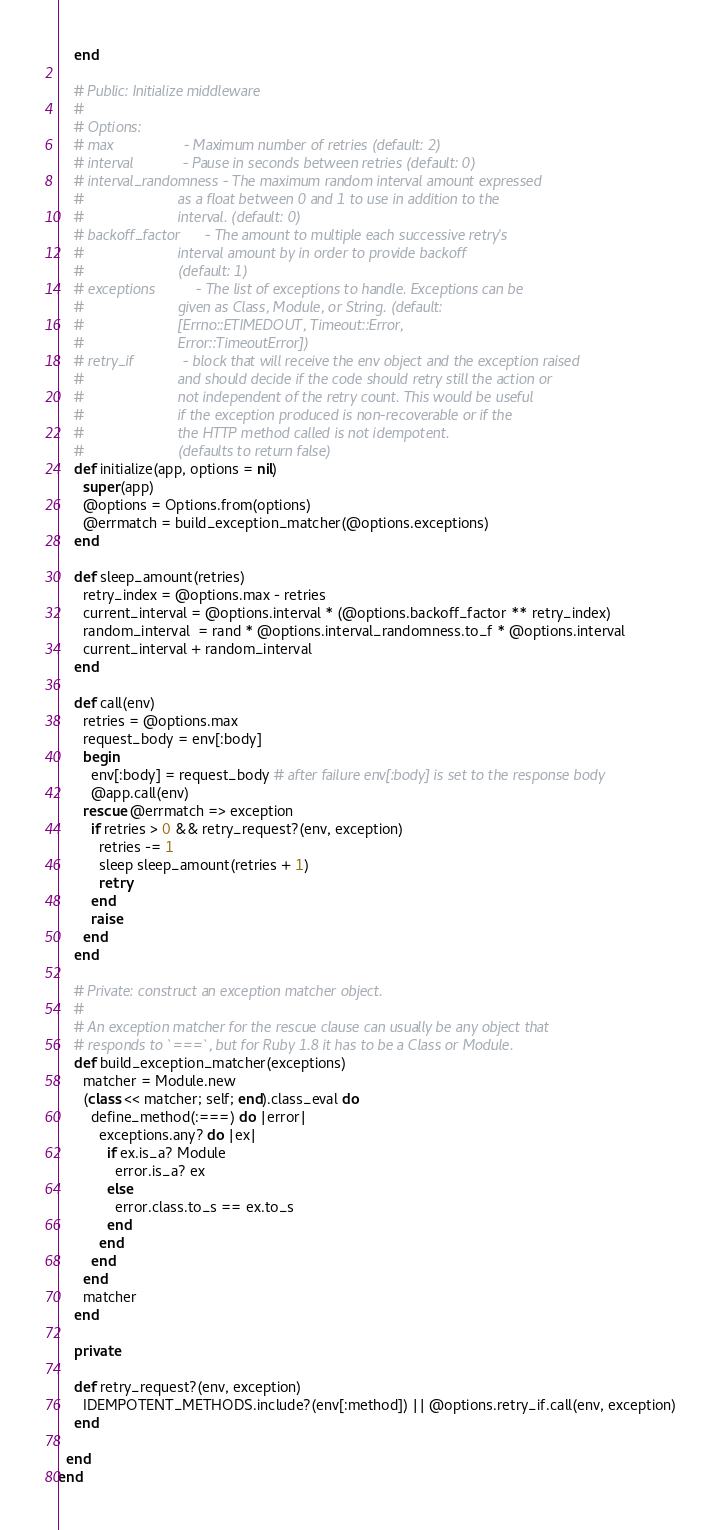<code> <loc_0><loc_0><loc_500><loc_500><_Ruby_>    end

    # Public: Initialize middleware
    #
    # Options:
    # max                 - Maximum number of retries (default: 2)
    # interval            - Pause in seconds between retries (default: 0)
    # interval_randomness - The maximum random interval amount expressed
    #                       as a float between 0 and 1 to use in addition to the
    #                       interval. (default: 0)
    # backoff_factor      - The amount to multiple each successive retry's
    #                       interval amount by in order to provide backoff
    #                       (default: 1)
    # exceptions          - The list of exceptions to handle. Exceptions can be
    #                       given as Class, Module, or String. (default:
    #                       [Errno::ETIMEDOUT, Timeout::Error,
    #                       Error::TimeoutError])
    # retry_if            - block that will receive the env object and the exception raised
    #                       and should decide if the code should retry still the action or
    #                       not independent of the retry count. This would be useful
    #                       if the exception produced is non-recoverable or if the
    #                       the HTTP method called is not idempotent.
    #                       (defaults to return false)
    def initialize(app, options = nil)
      super(app)
      @options = Options.from(options)
      @errmatch = build_exception_matcher(@options.exceptions)
    end

    def sleep_amount(retries)
      retry_index = @options.max - retries
      current_interval = @options.interval * (@options.backoff_factor ** retry_index)
      random_interval  = rand * @options.interval_randomness.to_f * @options.interval
      current_interval + random_interval
    end

    def call(env)
      retries = @options.max
      request_body = env[:body]
      begin
        env[:body] = request_body # after failure env[:body] is set to the response body
        @app.call(env)
      rescue @errmatch => exception
        if retries > 0 && retry_request?(env, exception)
          retries -= 1
          sleep sleep_amount(retries + 1)
          retry
        end
        raise
      end
    end

    # Private: construct an exception matcher object.
    #
    # An exception matcher for the rescue clause can usually be any object that
    # responds to `===`, but for Ruby 1.8 it has to be a Class or Module.
    def build_exception_matcher(exceptions)
      matcher = Module.new
      (class << matcher; self; end).class_eval do
        define_method(:===) do |error|
          exceptions.any? do |ex|
            if ex.is_a? Module
              error.is_a? ex
            else
              error.class.to_s == ex.to_s
            end
          end
        end
      end
      matcher
    end

    private

    def retry_request?(env, exception)
      IDEMPOTENT_METHODS.include?(env[:method]) || @options.retry_if.call(env, exception)
    end

  end
end
</code> 